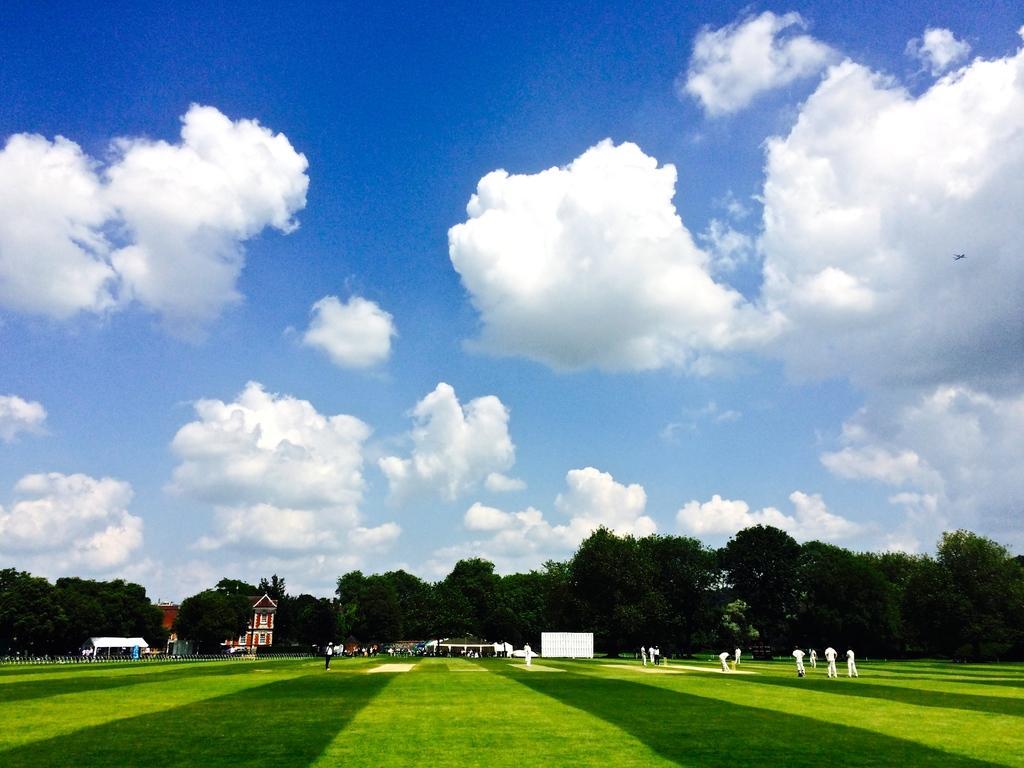In one or two sentences, can you explain what this image depicts? In the picture there is a ground, on the ground there are many people playing, there are many trees, there are buildings, there is a clear sky. 